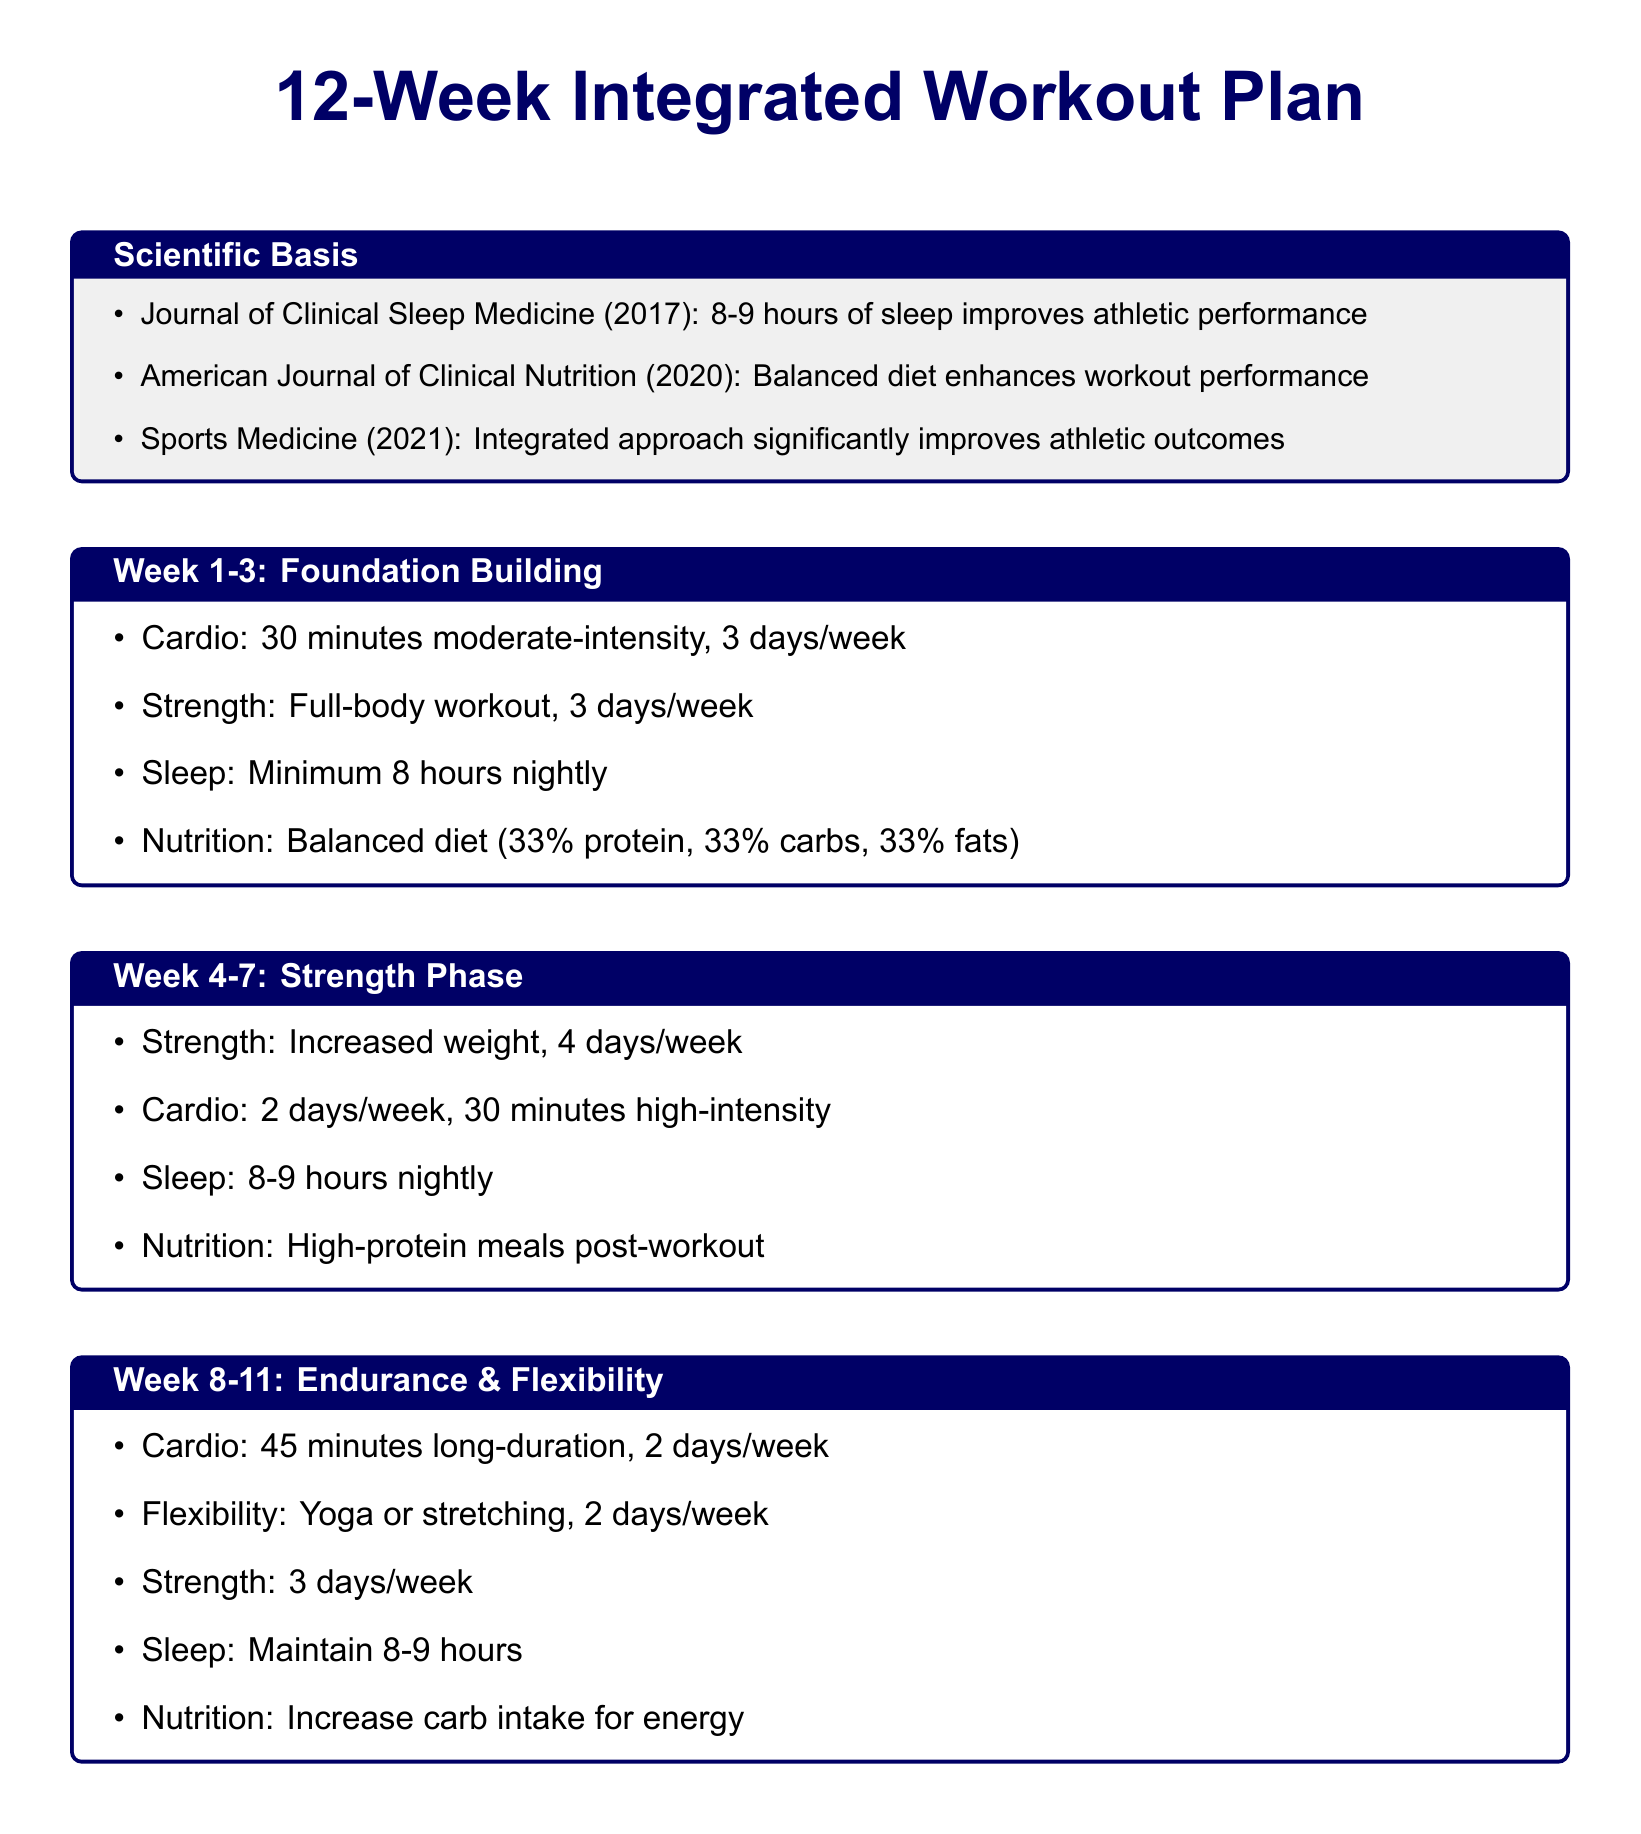What is the title of the workout plan? The title is stated at the top of the document and is “12-Week Integrated Workout Plan.”
Answer: 12-Week Integrated Workout Plan What is the recommended sleep duration for weeks 4-7? The recommended sleep duration is specified in the week content for this phase.
Answer: 8-9 hours nightly What type of workouts are included in week 12? The types of workouts in week 12 are detailed in the section for that week.
Answer: HIIT and Strength Which scientific journal mentioned in the plan supports the sleep duration recommendation? The document lists journals that provide empirical evidence.
Answer: Journal of Clinical Sleep Medicine What percentage of nutrition is allocated to protein in the foundation building phase? The nutritional breakdown is given clearly in the corresponding section.
Answer: 33% How many days per week is flexibility training included in weeks 8-11? The number of days is specified in the workout details for this phase.
Answer: 2 days/week What is the primary focus of weeks 8-11? The focus of these weeks is summarized in the title of that section.
Answer: Endurance & Flexibility What is the nutrition recommendation for week 12? The nutritional advice for week 12 is outlined explicitly in the respective section.
Answer: Optimized pre/post-workout meals What is indicated as a key takeaway regarding sleep? The key takeaway highlights the importance of sleep discussed in that section.
Answer: Enhances muscle recovery and reduces injury risk 